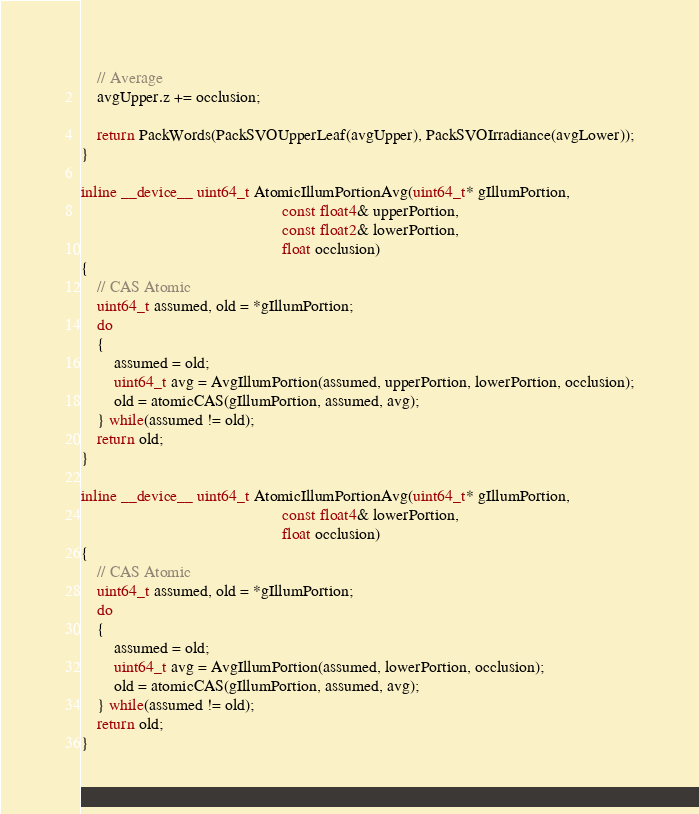<code> <loc_0><loc_0><loc_500><loc_500><_Cuda_>
	// Average
	avgUpper.z += occlusion;

	return PackWords(PackSVOUpperLeaf(avgUpper), PackSVOIrradiance(avgLower));
}

inline __device__ uint64_t AtomicIllumPortionAvg(uint64_t* gIllumPortion,
												 const float4& upperPortion,
												 const float2& lowerPortion,
												 float occlusion)
{
	// CAS Atomic
	uint64_t assumed, old = *gIllumPortion;
	do
	{
		assumed = old;
		uint64_t avg = AvgIllumPortion(assumed, upperPortion, lowerPortion, occlusion);
		old = atomicCAS(gIllumPortion, assumed, avg);
	} while(assumed != old);
	return old;
}

inline __device__ uint64_t AtomicIllumPortionAvg(uint64_t* gIllumPortion,
												 const float4& lowerPortion,
												 float occlusion)
{
	// CAS Atomic
	uint64_t assumed, old = *gIllumPortion;
	do
	{
		assumed = old;
		uint64_t avg = AvgIllumPortion(assumed, lowerPortion, occlusion);
		old = atomicCAS(gIllumPortion, assumed, avg);
	} while(assumed != old);
	return old;
}</code> 